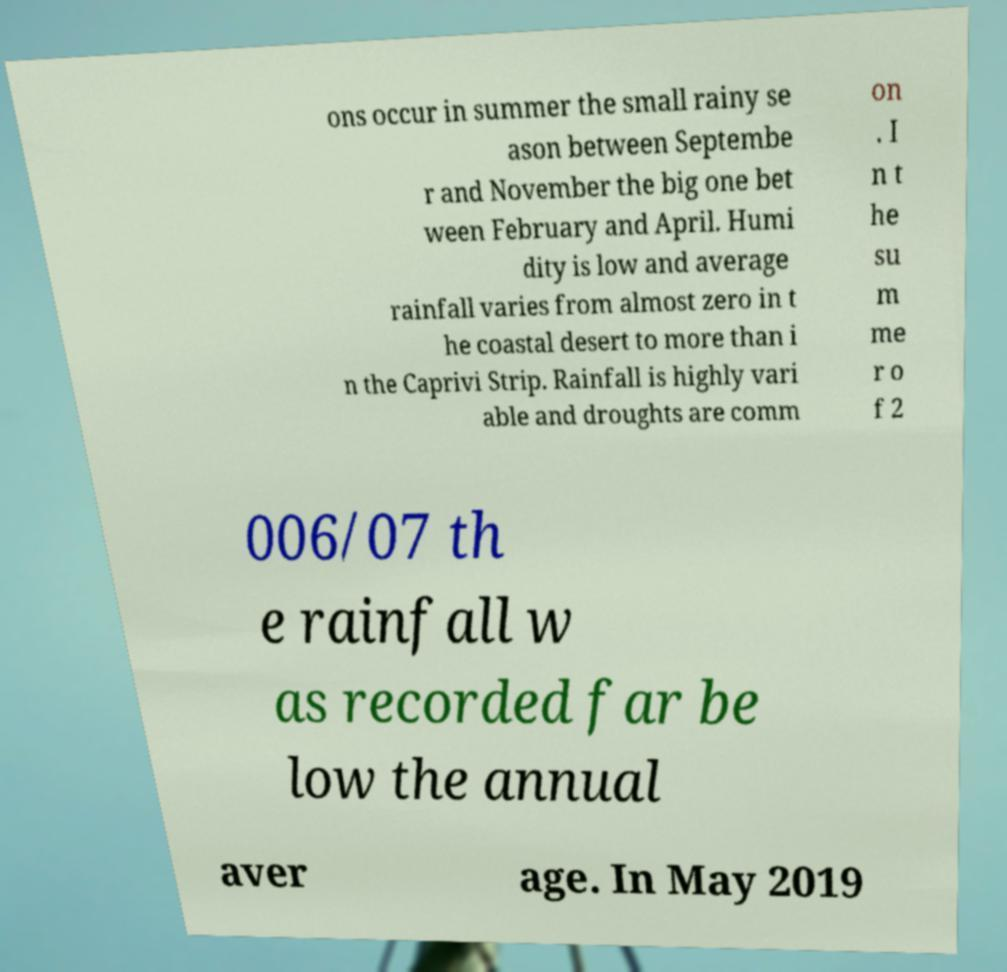Please identify and transcribe the text found in this image. ons occur in summer the small rainy se ason between Septembe r and November the big one bet ween February and April. Humi dity is low and average rainfall varies from almost zero in t he coastal desert to more than i n the Caprivi Strip. Rainfall is highly vari able and droughts are comm on . I n t he su m me r o f 2 006/07 th e rainfall w as recorded far be low the annual aver age. In May 2019 